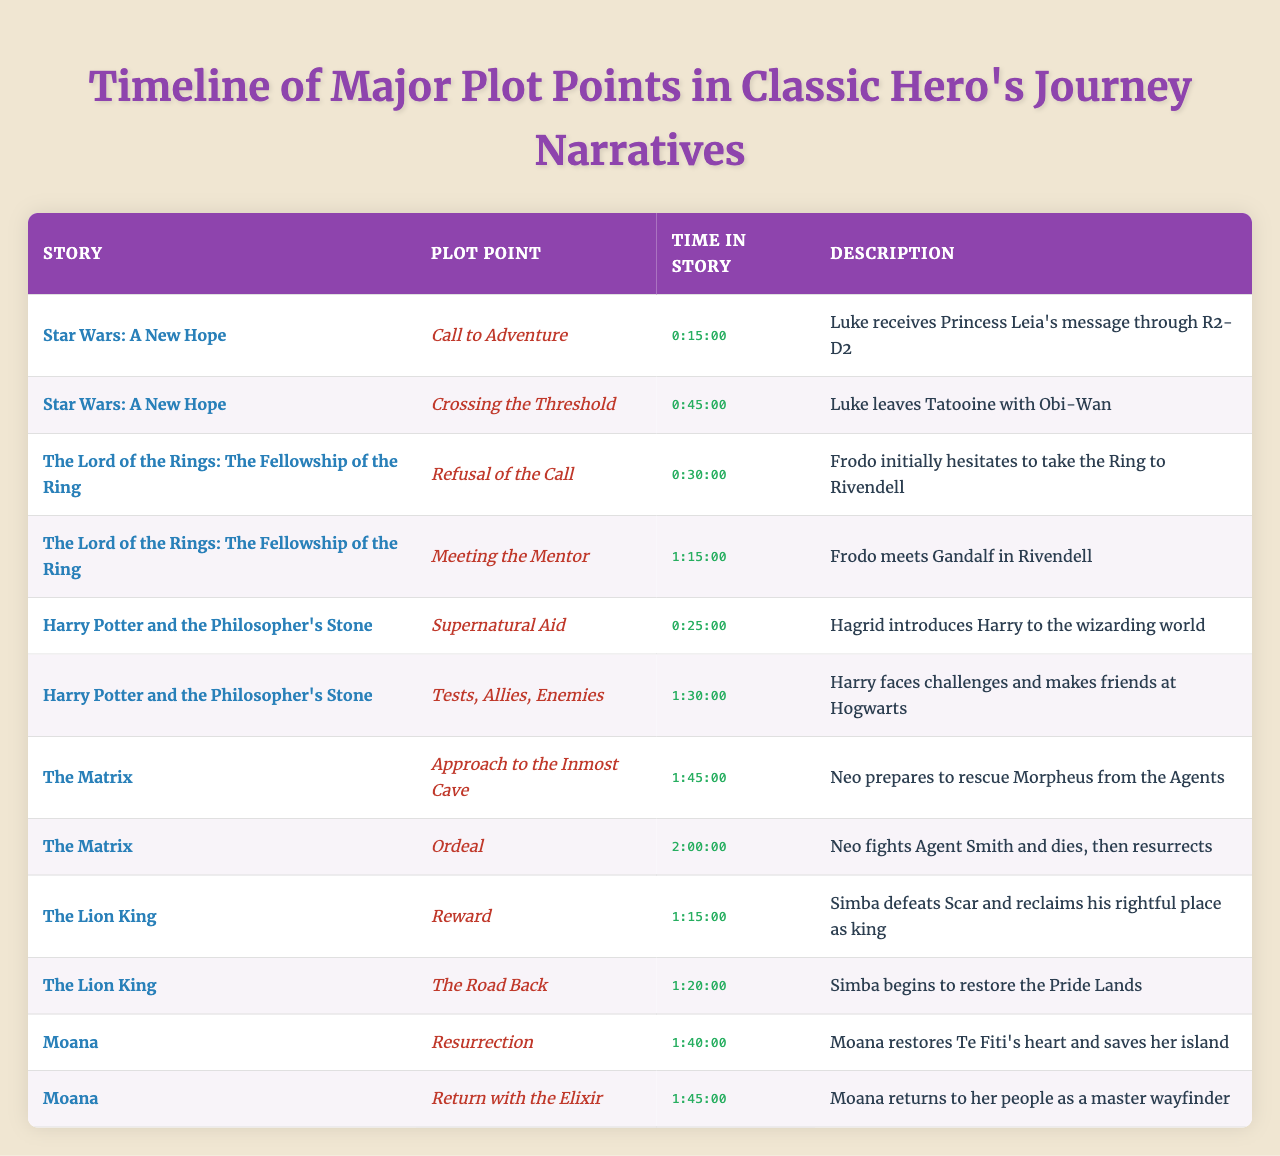What is the plot point that occurs first in "Star Wars: A New Hope"? Looking at the timeline, the first plot point listed for "Star Wars: A New Hope" is "Call to Adventure," which occurs at 0:15:00 into the story.
Answer: Call to Adventure How much time passes between "Supernatural Aid" and "Tests, Allies, Enemies" in "Harry Potter and the Philosopher's Stone"? "Supernatural Aid" occurs at 0:25:00 and "Tests, Allies, Enemies" occurs at 1:30:00. The difference in time is 1:30:00 - 0:25:00, which is 1 hour and 5 minutes.
Answer: 1 hour 5 minutes Which story has the "Ordeal" plot point last? The last "Ordeal" plot point in the table belongs to "The Matrix" as it occurs at 2:00:00, and there are no other plot points listed after that.
Answer: The Matrix Does "Moana" feature a "Return with the Elixir" plot point? Yes, the table lists "Return with the Elixir" as a plot point for "Moana."
Answer: Yes What is the average time of all plot points in "The Lord of the Rings: The Fellowship of the Ring"? The plot points for "The Lord of the Rings: The Fellowship of the Ring" occur at 0:30:00 and 1:15:00. Converting these times into minutes gives us 30 and 75 minutes. Adding these up gives 105 minutes, then dividing by the number of plot points (2) gives us 105/2 which is 52.5 minutes.
Answer: 52.5 minutes Which story has the plot point "Crossing the Threshold" and at what time does it occur? "Crossing the Threshold" is associated with "Star Wars: A New Hope," and it occurs at 0:45:00 in the story.
Answer: Star Wars: A New Hope at 0:45:00 How many stories feature the plot point "Meeting the Mentor"? Only "The Lord of the Rings: The Fellowship of the Ring" features the "Meeting the Mentor" plot point, as seen in the table.
Answer: One story What can be concluded about the order of events in "The Lion King"? The table shows "Reward" occurs at 1:15:00 followed by "The Road Back" at 1:20:00; thus, "Reward" happens before "The Road Back," indicating a sequential progression from triumph to restoration.
Answer: Reward before The Road Back 